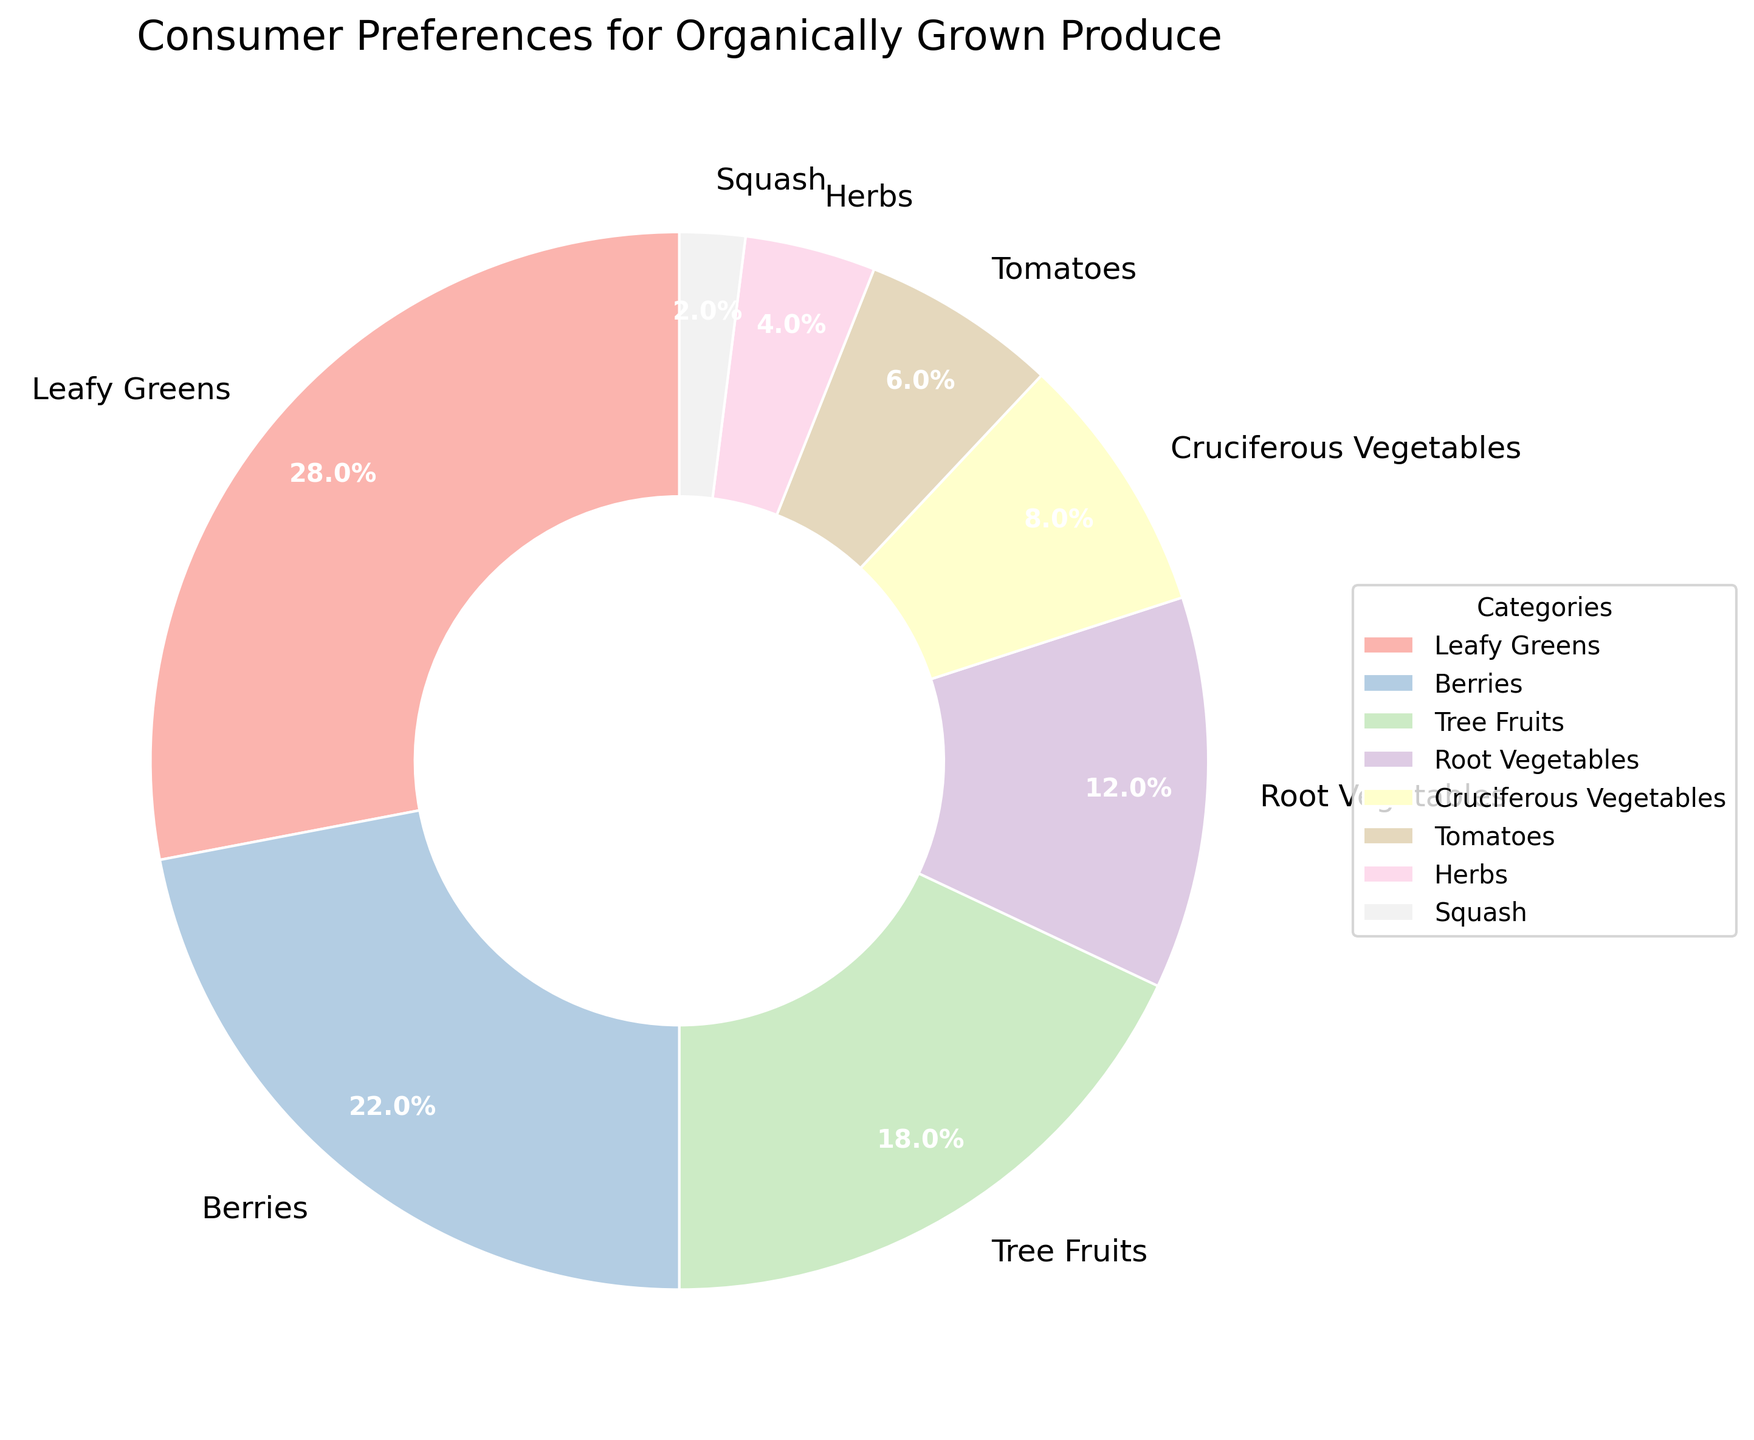Which category of produce has the highest consumer preference for organically grown options? The category with the highest percentage in the pie chart represents the highest consumer preference. Here, 'Leafy Greens' has the highest percentage.
Answer: Leafy Greens Which three categories have the highest consumer preference percentages? To find the top three categories, list the categories and their percentages in descending order. The top three are 'Leafy Greens' (28%), 'Berries' (22%), and 'Tree Fruits' (18%).
Answer: Leafy Greens, Berries, Tree Fruits Are leafy greens or tomatoes more preferred organically? Compare the percentages of 'Leafy Greens' and 'Tomatoes'. 'Leafy Greens' at 28% is higher than 'Tomatoes' at 6%.
Answer: Leafy Greens What is the total preference for organically grown root vegetables and cruciferous vegetables? Add the percentages for 'Root Vegetables' (12%) and 'Cruciferous Vegetables' (8%). 12% + 8% = 20%
Answer: 20% If 'Herbs' and 'Squash' are combined, what is their total preference percentage? Add the percentages for 'Herbs' (4%) and 'Squash' (2%). 4% + 2% = 6%
Answer: 6% What is the difference in preference percentage between berries and leafy greens? Subtract the percentage of 'Berries' (22%) from 'Leafy Greens' (28%). 28% - 22% = 6%
Answer: 6% Which is preferred more, root vegetables or tree fruits? Compare the percentages of 'Root Vegetables' (12%) and 'Tree Fruits' (18%). 'Tree Fruits' at 18% is higher than 'Root Vegetables' at 12%.
Answer: Tree Fruits How do cruciferous vegetables and tomatoes compare in terms of consumer preference percentage? Compare the percentages of 'Cruciferous Vegetables' (8%) and 'Tomatoes' (6%). 'Cruciferous Vegetables' are more preferred at 8%.
Answer: Cruciferous Vegetables What percentage of consumers prefer tree fruits over root vegetables? Subtract the percentage of 'Root Vegetables' (12%) from 'Tree Fruits' (18%). 18% - 12% = 6%
Answer: 6% What is the percentage difference between the most preferred and least preferred categories? Subtract the percentage of the least preferred category 'Squash' (2%) from the most preferred category 'Leafy Greens' (28%). 28% - 2% = 26%
Answer: 26% 